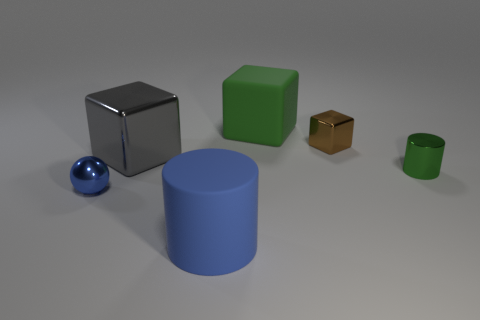Add 2 rubber cylinders. How many objects exist? 8 Subtract all big blocks. How many blocks are left? 1 Subtract all brown blocks. How many blocks are left? 2 Subtract all blue rubber blocks. Subtract all large blue matte cylinders. How many objects are left? 5 Add 6 small metallic cubes. How many small metallic cubes are left? 7 Add 2 tiny blue metal balls. How many tiny blue metal balls exist? 3 Subtract 0 red cylinders. How many objects are left? 6 Subtract all cylinders. How many objects are left? 4 Subtract 1 blocks. How many blocks are left? 2 Subtract all yellow blocks. Subtract all cyan cylinders. How many blocks are left? 3 